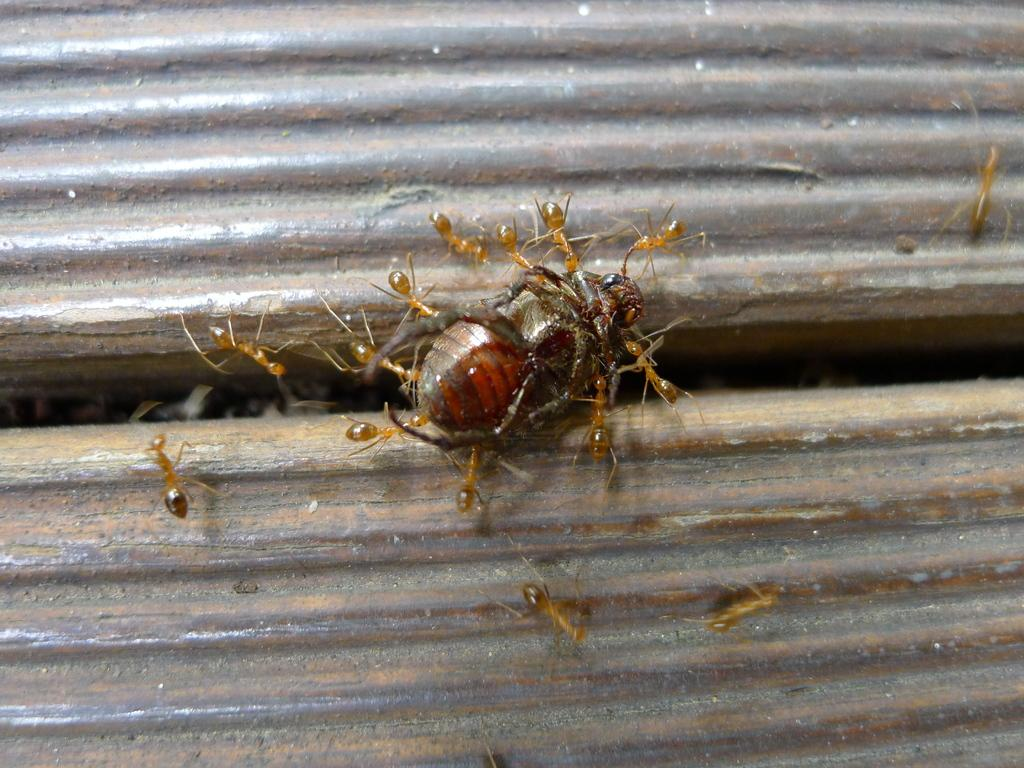What type of creature can be seen in the image? There is an insect in the image. What other creatures are present in the image? There are ants in the image. What material are the insect and ants resting on? The insect and ants are on iron objects. What type of representative is present at the feast in the image? There is no feast or representative present in the image; it features an insect and ants on iron objects. What idea does the insect have about the ants in the image? There is no indication of any ideas or thoughts in the image; it simply shows an insect and ants on iron objects. 